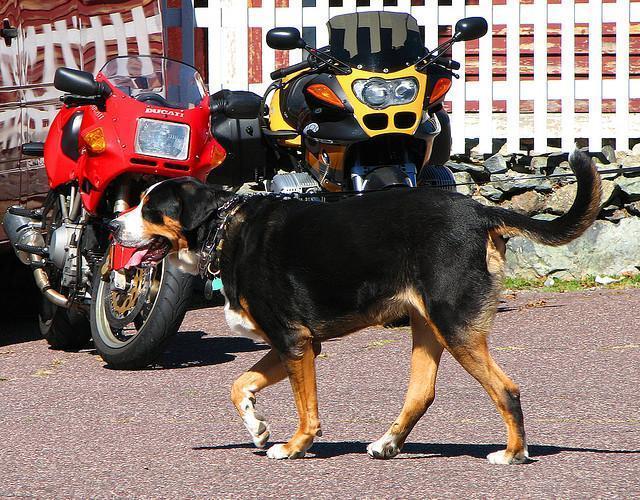How many motorbikes are near the dog?
Give a very brief answer. 2. How many motorcycles are visible?
Give a very brief answer. 2. 